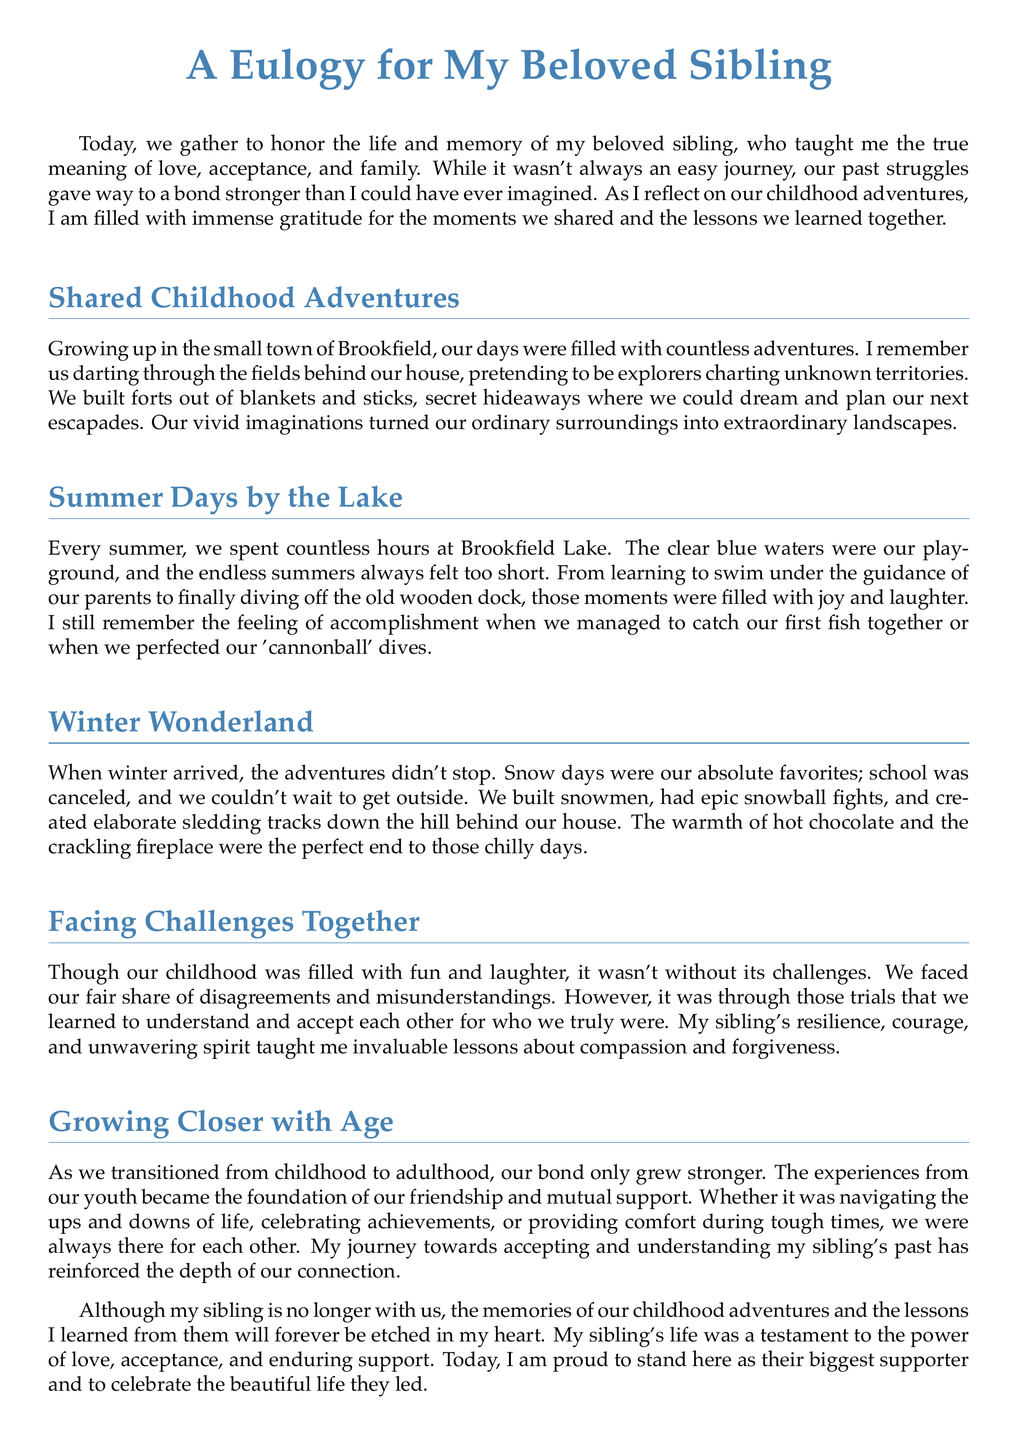What does the eulogy honor? The eulogy honors the life and memory of the speaker's beloved sibling.
Answer: life and memory of my beloved sibling Where did the childhood adventures take place? The childhood adventures took place in the small town of Brookfield.
Answer: Brookfield What was a favorite activity during summer? A favorite activity during summer was spending hours at Brookfield Lake.
Answer: spending hours at Brookfield Lake What did the siblings build in winter? The siblings built snowmen during winter adventures.
Answer: snowmen What lesson did the speaker learn from their sibling? The speaker learned invaluable lessons about compassion and forgiveness.
Answer: compassion and forgiveness How did the bond change over time? The bond grew stronger as they transitioned to adulthood.
Answer: grew stronger What was the reaction to challenges faced? The challenges led to better understanding and acceptance of each other.
Answer: understanding and acceptance What was celebrated together? Achievements were celebrated together.
Answer: achievements 